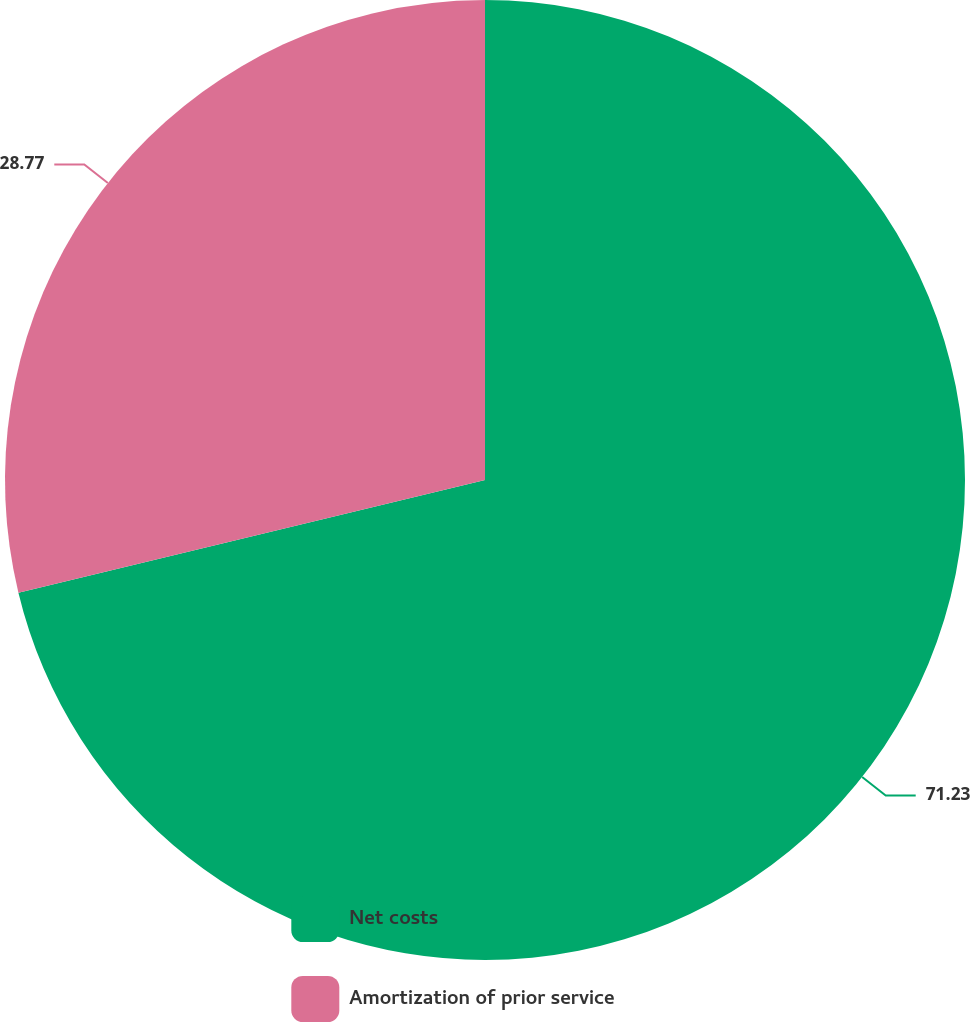<chart> <loc_0><loc_0><loc_500><loc_500><pie_chart><fcel>Net costs<fcel>Amortization of prior service<nl><fcel>71.23%<fcel>28.77%<nl></chart> 